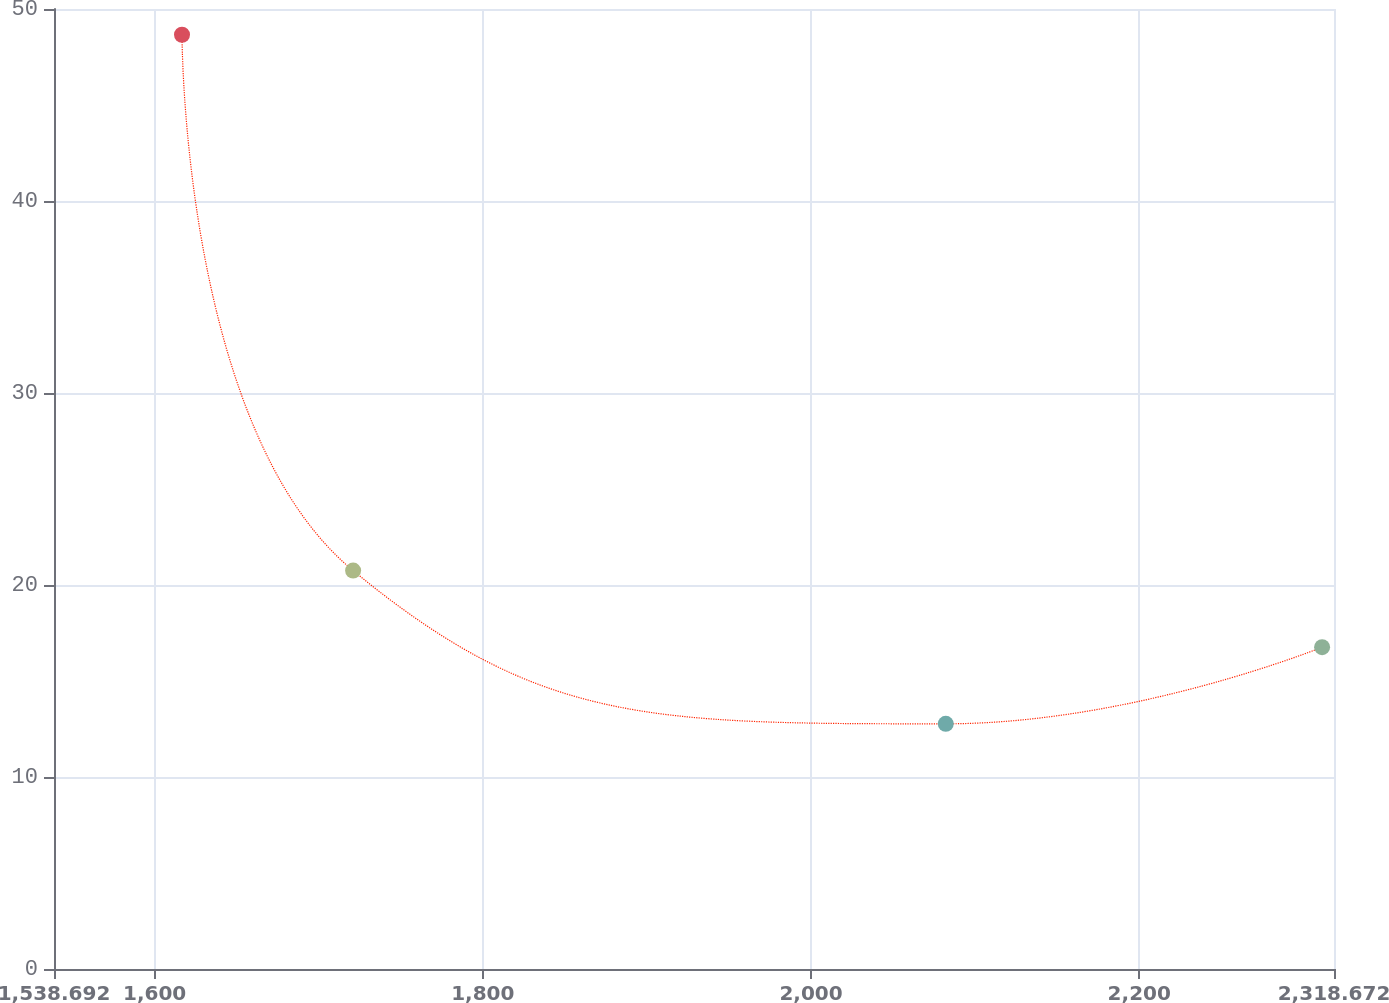Convert chart to OTSL. <chart><loc_0><loc_0><loc_500><loc_500><line_chart><ecel><fcel>( in millions)<nl><fcel>1616.69<fcel>48.66<nl><fcel>1720.96<fcel>20.75<nl><fcel>2082.09<fcel>12.77<nl><fcel>2311.42<fcel>16.76<nl><fcel>2396.67<fcel>8.78<nl></chart> 